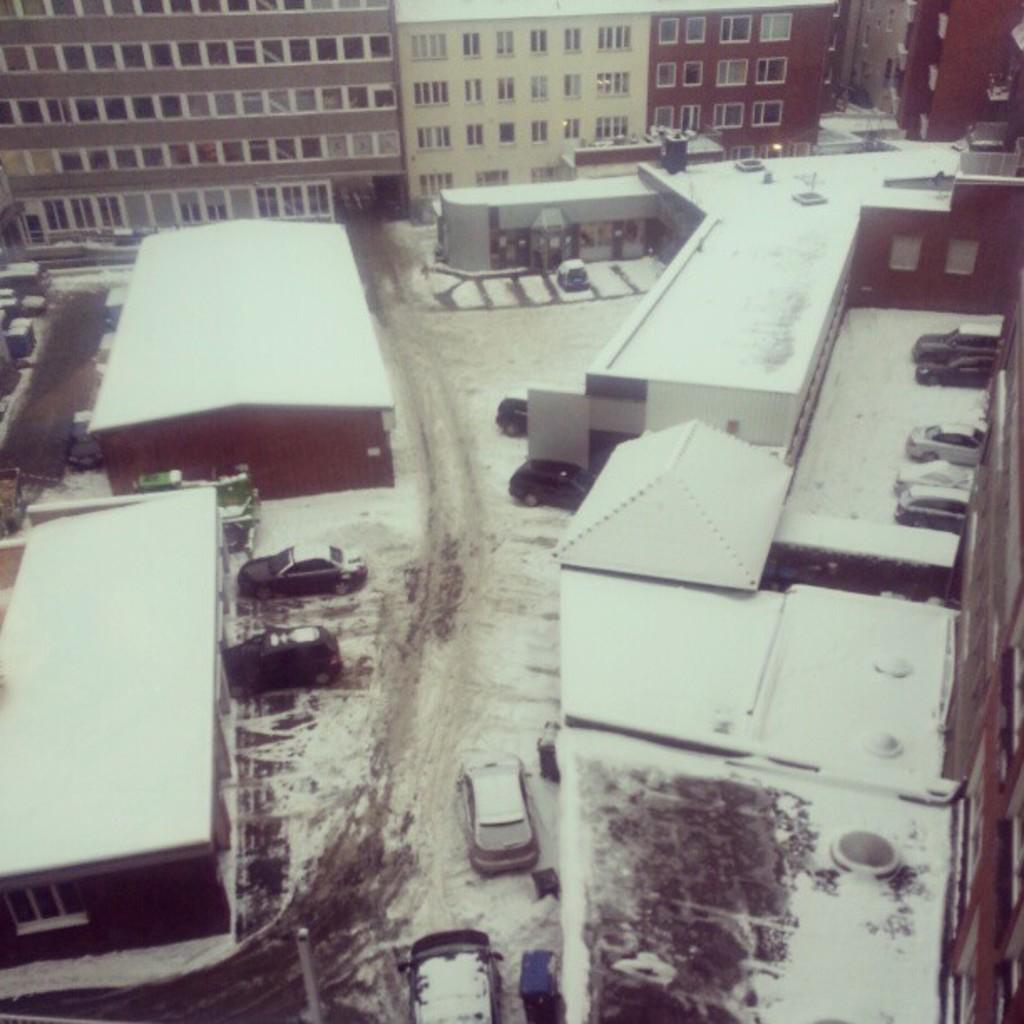What is the main subject in the center of the image? There are cars in the center of the image. What else can be seen in the image besides the cars? There are buildings in the image, and snow is present on top of the buildings. Are there any buildings visible in the background of the image? Yes, there are buildings visible in the background of the image. What type of wood is used to build the muscle in the image? There is no wood or muscle present in the image; it features cars and buildings with snow on top. 